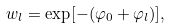Convert formula to latex. <formula><loc_0><loc_0><loc_500><loc_500>w _ { l } = \exp [ - ( \varphi _ { 0 } + \varphi _ { l } ) ] ,</formula> 